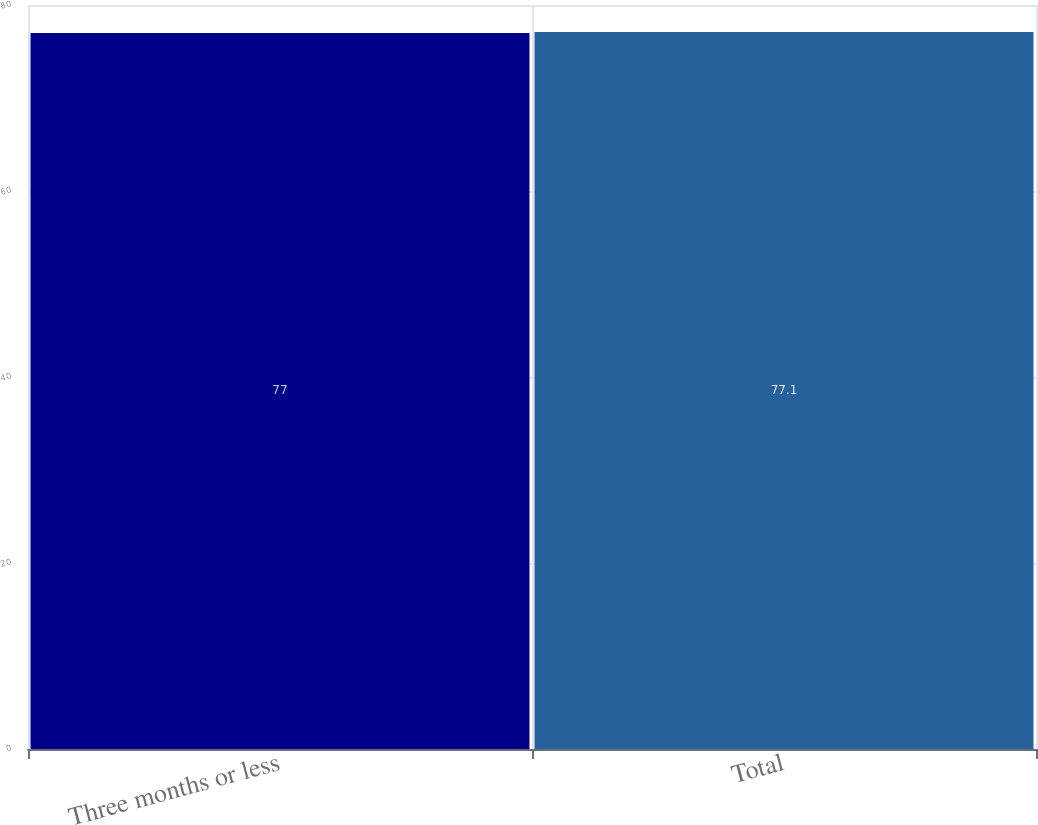Convert chart to OTSL. <chart><loc_0><loc_0><loc_500><loc_500><bar_chart><fcel>Three months or less<fcel>Total<nl><fcel>77<fcel>77.1<nl></chart> 